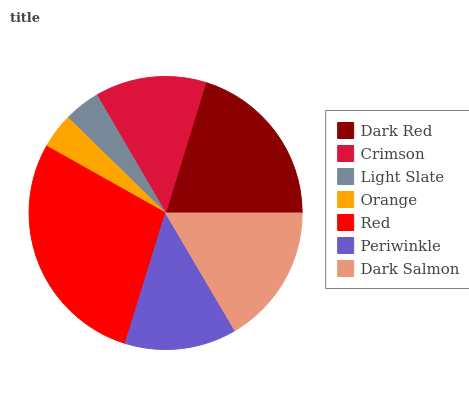Is Orange the minimum?
Answer yes or no. Yes. Is Red the maximum?
Answer yes or no. Yes. Is Crimson the minimum?
Answer yes or no. No. Is Crimson the maximum?
Answer yes or no. No. Is Dark Red greater than Crimson?
Answer yes or no. Yes. Is Crimson less than Dark Red?
Answer yes or no. Yes. Is Crimson greater than Dark Red?
Answer yes or no. No. Is Dark Red less than Crimson?
Answer yes or no. No. Is Periwinkle the high median?
Answer yes or no. Yes. Is Periwinkle the low median?
Answer yes or no. Yes. Is Red the high median?
Answer yes or no. No. Is Red the low median?
Answer yes or no. No. 